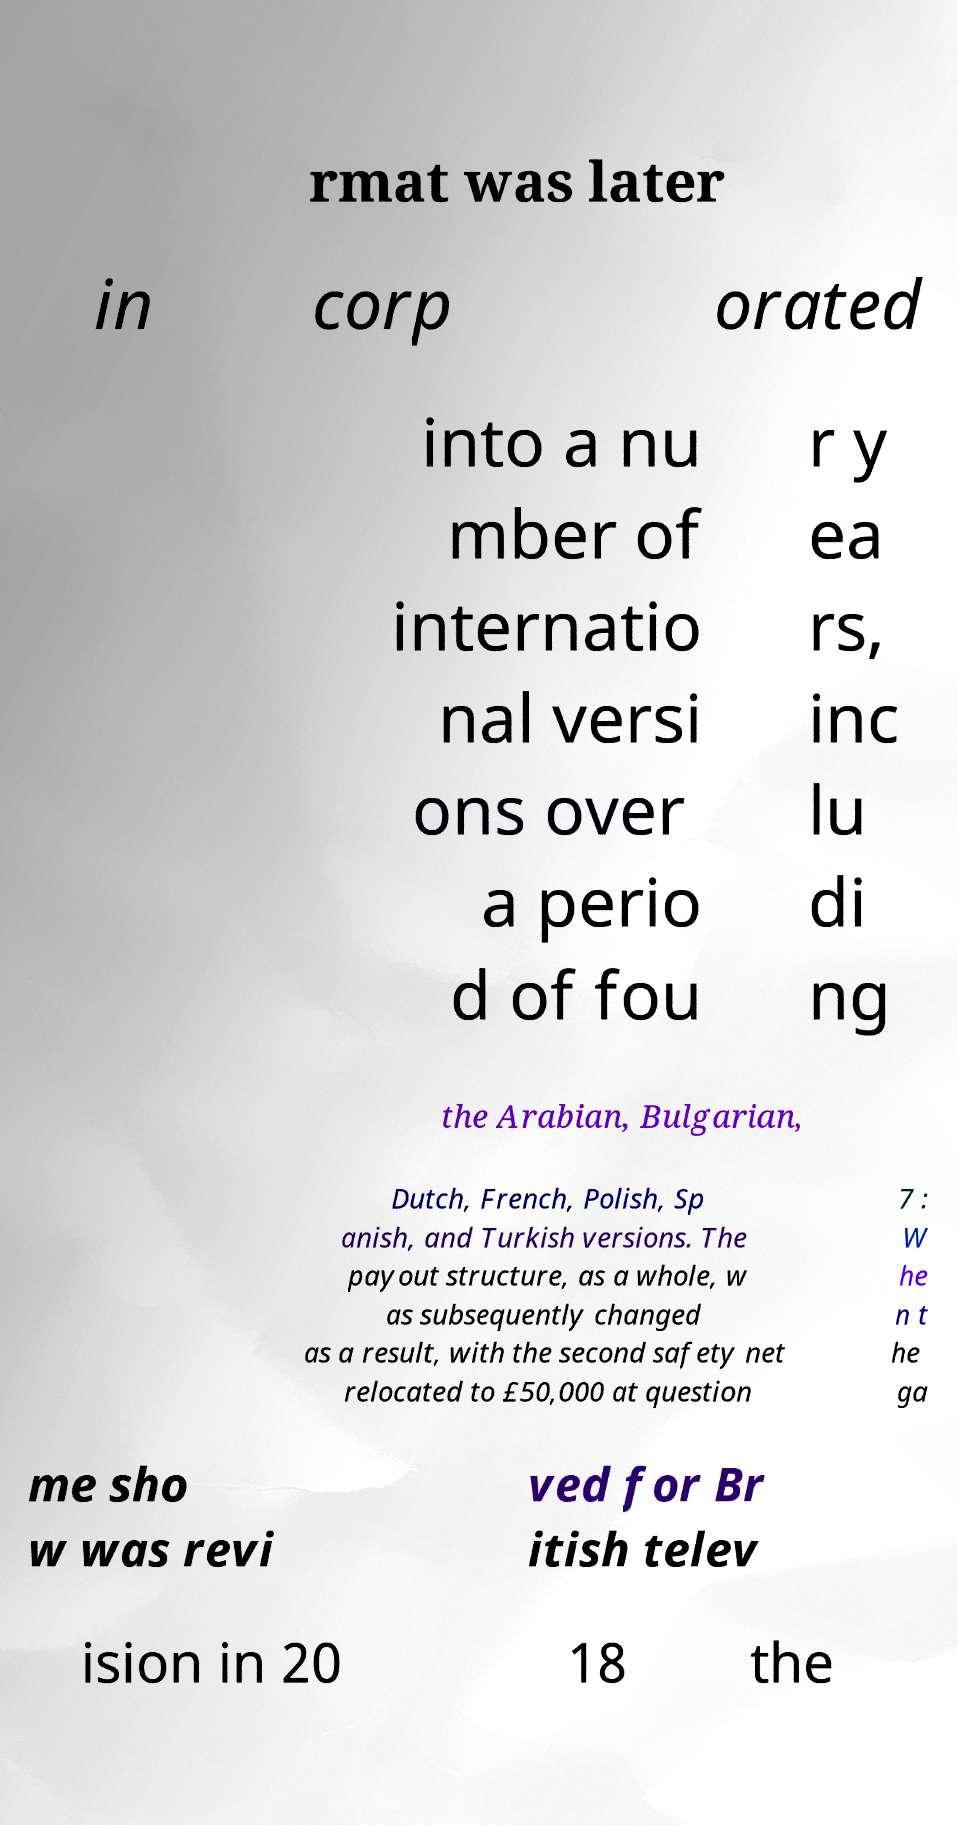I need the written content from this picture converted into text. Can you do that? rmat was later in corp orated into a nu mber of internatio nal versi ons over a perio d of fou r y ea rs, inc lu di ng the Arabian, Bulgarian, Dutch, French, Polish, Sp anish, and Turkish versions. The payout structure, as a whole, w as subsequently changed as a result, with the second safety net relocated to £50,000 at question 7 : W he n t he ga me sho w was revi ved for Br itish telev ision in 20 18 the 